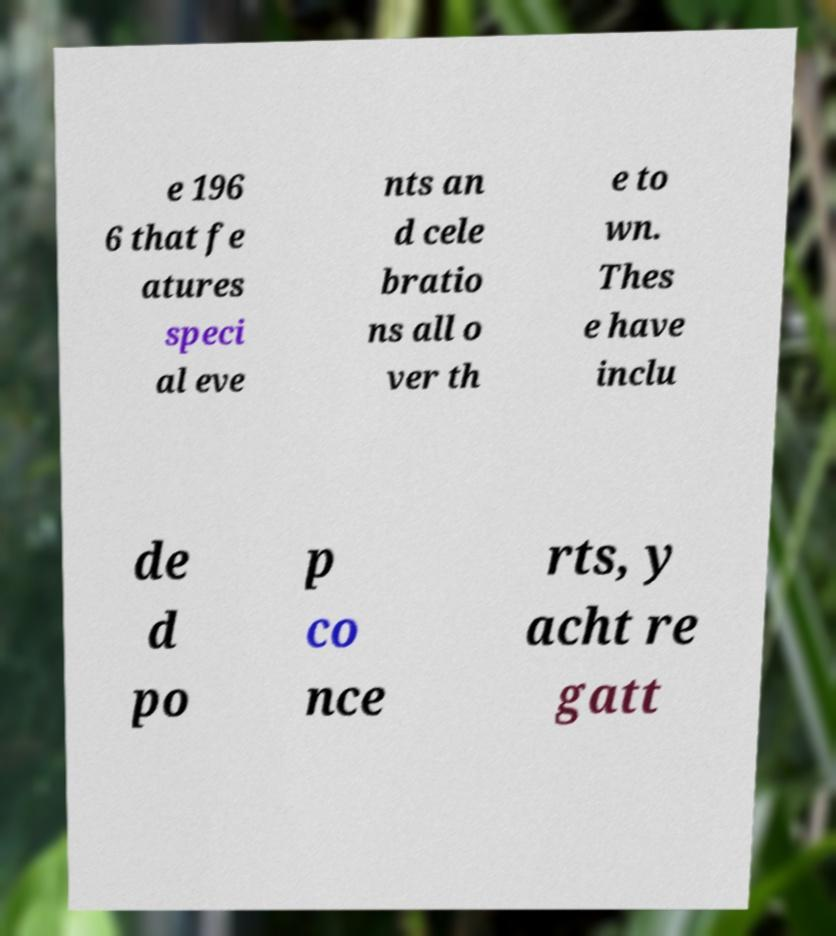Could you extract and type out the text from this image? e 196 6 that fe atures speci al eve nts an d cele bratio ns all o ver th e to wn. Thes e have inclu de d po p co nce rts, y acht re gatt 